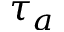<formula> <loc_0><loc_0><loc_500><loc_500>\tau _ { a }</formula> 